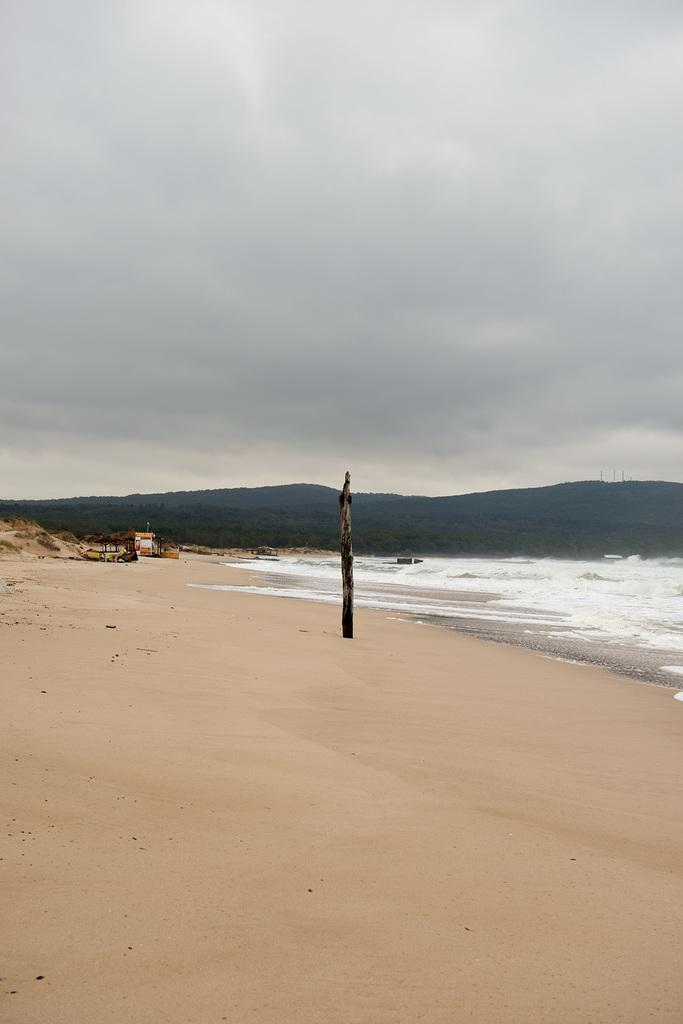What is visible in the image? Water is visible in the image. What can be seen in the background of the image? There is a boat and hills visible in the background of the image. How does the cat kick the milk in the image? There is no cat or milk present in the image. 